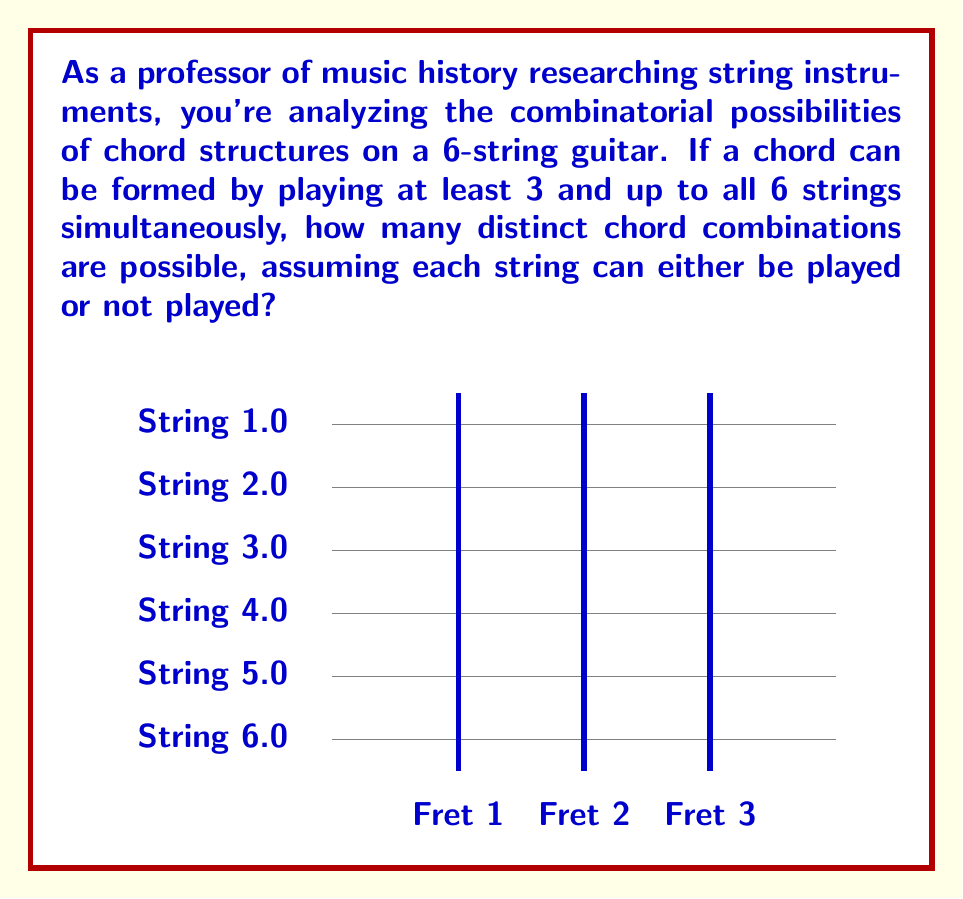What is the answer to this math problem? Let's approach this step-by-step:

1) We need to consider all possible combinations of 3, 4, 5, and 6 strings being played.

2) This is a perfect scenario for using the combination formula. For each case, we'll calculate $\binom{6}{k}$, where 6 is the total number of strings and k is the number of strings being played.

3) For 3 strings: $\binom{6}{3} = \frac{6!}{3!(6-3)!} = \frac{6!}{3!3!} = 20$

4) For 4 strings: $\binom{6}{4} = \frac{6!}{4!(6-4)!} = \frac{6!}{4!2!} = 15$

5) For 5 strings: $\binom{6}{5} = \frac{6!}{5!(6-5)!} = \frac{6!}{5!1!} = 6$

6) For 6 strings: $\binom{6}{6} = \frac{6!}{6!(6-6)!} = \frac{6!}{6!0!} = 1$

7) The total number of possible chord combinations is the sum of all these:

   $$ \text{Total} = \binom{6}{3} + \binom{6}{4} + \binom{6}{5} + \binom{6}{6} $$
   $$ = 20 + 15 + 6 + 1 = 42 $$

Therefore, there are 42 distinct chord combinations possible.
Answer: 42 chord combinations 